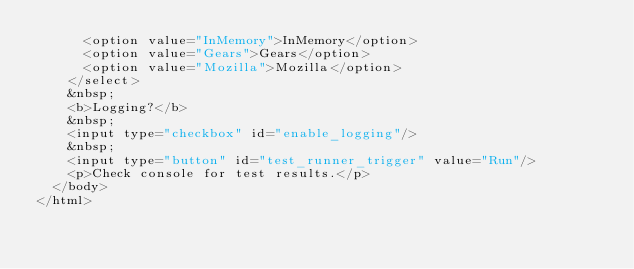Convert code to text. <code><loc_0><loc_0><loc_500><loc_500><_HTML_>      <option value="InMemory">InMemory</option>
      <option value="Gears">Gears</option>
      <option value="Mozilla">Mozilla</option>
    </select>
    &nbsp;
    <b>Logging?</b>
    &nbsp;
    <input type="checkbox" id="enable_logging"/>
    &nbsp;
    <input type="button" id="test_runner_trigger" value="Run"/>
    <p>Check console for test results.</p>
  </body>
</html>
</code> 